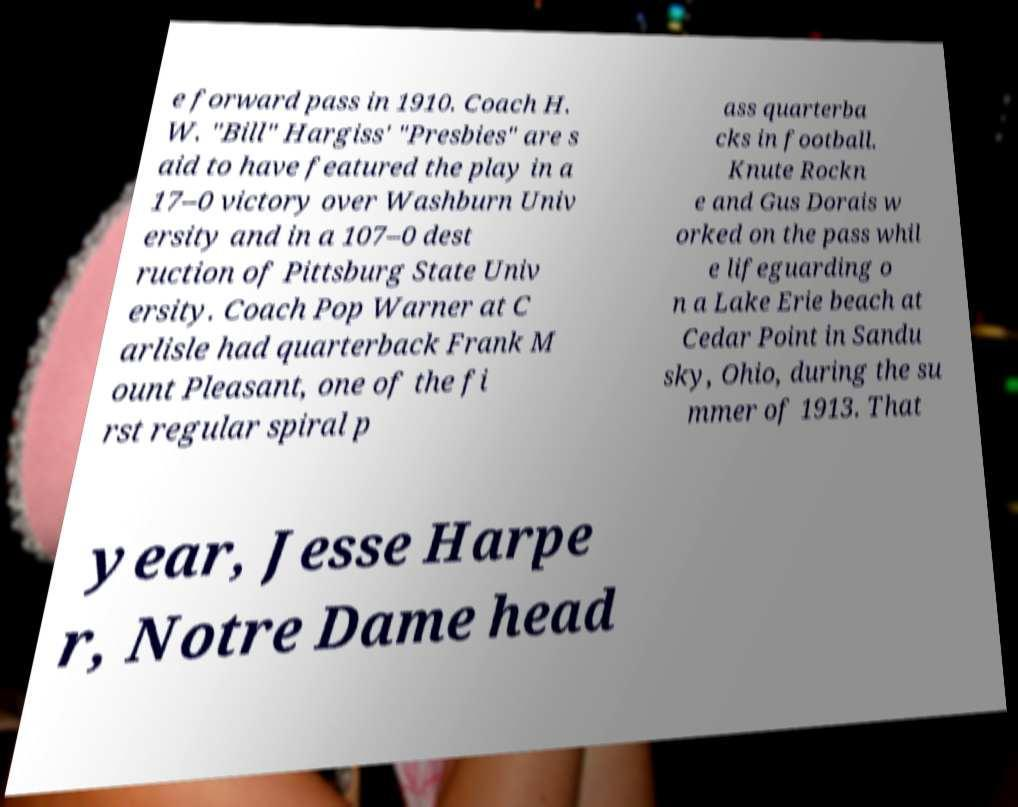Can you accurately transcribe the text from the provided image for me? e forward pass in 1910. Coach H. W. "Bill" Hargiss' "Presbies" are s aid to have featured the play in a 17–0 victory over Washburn Univ ersity and in a 107–0 dest ruction of Pittsburg State Univ ersity. Coach Pop Warner at C arlisle had quarterback Frank M ount Pleasant, one of the fi rst regular spiral p ass quarterba cks in football. Knute Rockn e and Gus Dorais w orked on the pass whil e lifeguarding o n a Lake Erie beach at Cedar Point in Sandu sky, Ohio, during the su mmer of 1913. That year, Jesse Harpe r, Notre Dame head 